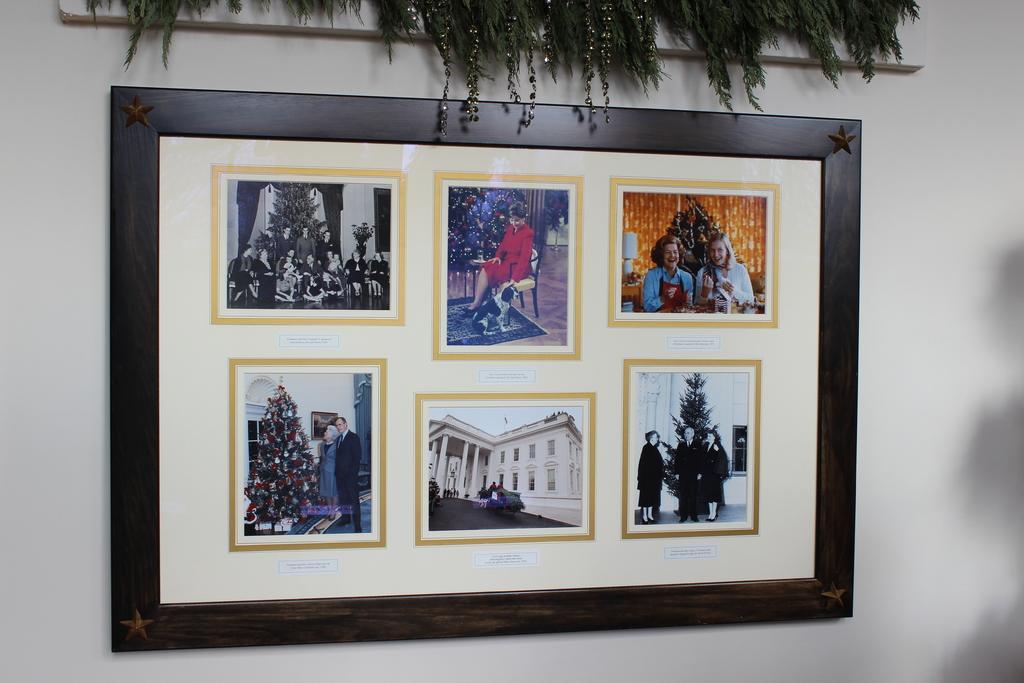Describe this image in one or two sentences. In this image we can see a photo frame on the wall with images of a few people, also we can see houseplants. 